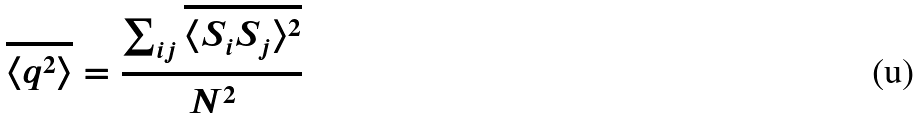Convert formula to latex. <formula><loc_0><loc_0><loc_500><loc_500>\overline { \langle q ^ { 2 } \rangle } = \frac { \sum _ { i j } \overline { \langle S _ { i } S _ { j } \rangle ^ { 2 } } } { N ^ { 2 } }</formula> 